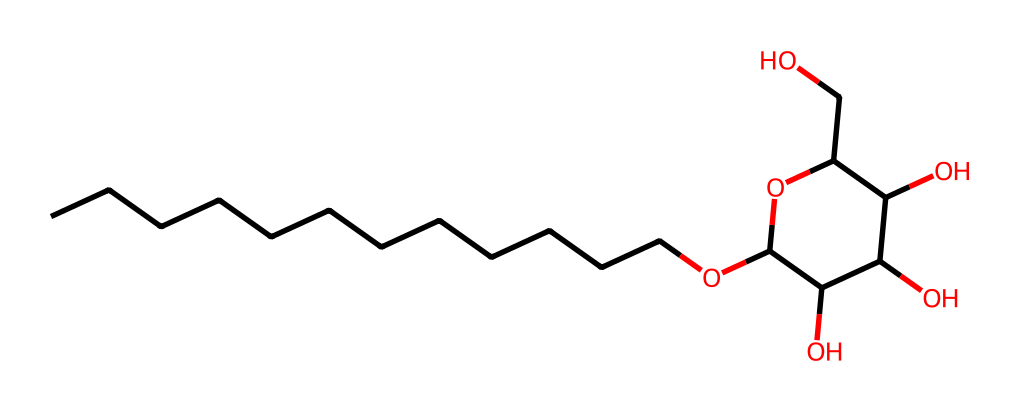How many carbon atoms are in this structure? By examining the SMILES notation, we can count the 'C' atoms before the 'O' and within the cyclic lauryl C12 structure, yielding 12 carbon atoms in total.
Answer: twelve What type of functional group is present in the structure? The SMILES notation shows several -OH (hydroxyl) groups, indicating that this compound contains multiple alcohol functional groups as part of its structure.
Answer: hydroxyl How many oxygen atoms are in the alkyl polyglucoside molecule? From the SMILES representation, we can count three 'O' atoms that are part of hydroxyl groups and the ether linkage, resulting in a total of four oxygen atoms.
Answer: four What makes this compound an eco-friendly surfactant? The use of renewable and biodegradable sources, such as glucose and fatty alcohols, along with the ability to lower surface tension makes it a suitable choice for eco-friendly cleaning.
Answer: renewable How does alkyl polyglucoside improve cleaning properties? The hydrophobic alkyl chain interacts with grease and oils, while the hydrophilic glucose part interacts with water, allowing for effective dirt removal and emulsification.
Answer: emulsification What is the cyclic structure present in this compound? The compound contains a pyranose ring which is a six-membered ring commonly found in sugar derivatives, contributing to its overall chemical structure.
Answer: pyranose What category of surfactant does this chemical belong to? Given its structure and properties, this compound is classified as a nonionic surfactant since it does not carry an electric charge and is less likely to irritate the skin.
Answer: nonionic 